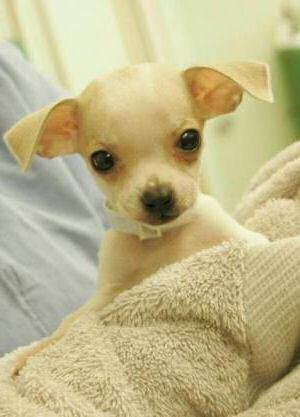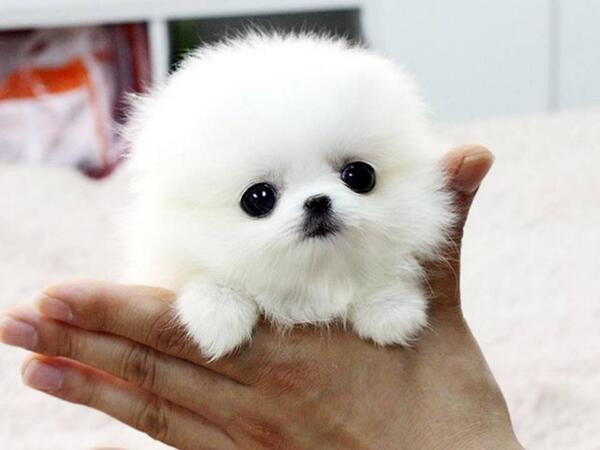The first image is the image on the left, the second image is the image on the right. For the images displayed, is the sentence "There are two puppies and at least one of them is not looking at the camera." factually correct? Answer yes or no. No. 